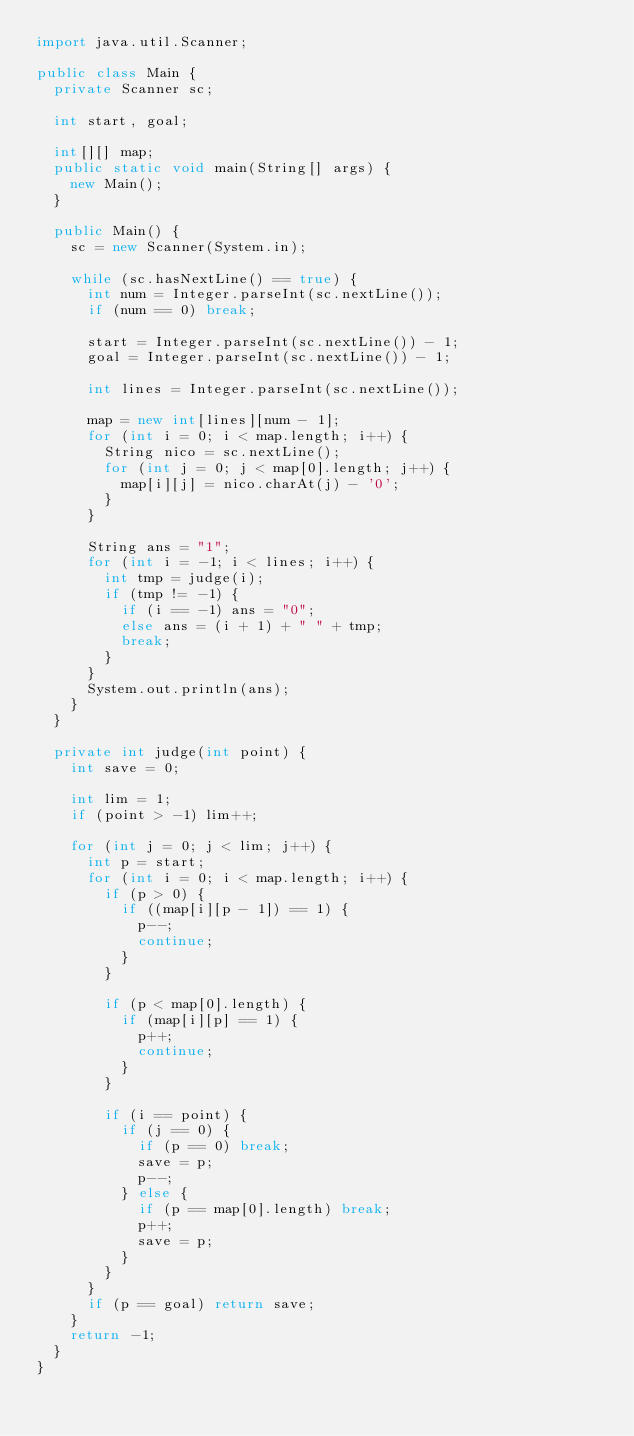<code> <loc_0><loc_0><loc_500><loc_500><_Java_>import java.util.Scanner;

public class Main {
	private Scanner sc;
	
	int start, goal;
	
	int[][] map;
	public static void main(String[] args) {
		new Main();
	}
	
	public Main() {
		sc = new Scanner(System.in);
		
		while (sc.hasNextLine() == true) {
			int num = Integer.parseInt(sc.nextLine());
			if (num == 0) break;
			
			start = Integer.parseInt(sc.nextLine()) - 1;
			goal = Integer.parseInt(sc.nextLine()) - 1;
			
			int lines = Integer.parseInt(sc.nextLine());
			
			map = new int[lines][num - 1];
			for (int i = 0; i < map.length; i++) {
				String nico = sc.nextLine();
				for (int j = 0; j < map[0].length; j++) {
					map[i][j] = nico.charAt(j) - '0';
				}
			}
			
			String ans = "1";
			for (int i = -1; i < lines; i++) {
				int tmp = judge(i);
				if (tmp != -1) {
					if (i == -1) ans = "0";
					else ans = (i + 1) + " " + tmp;
					break;
				}
			}
			System.out.println(ans);
		}
	}
	
	private int judge(int point) {
		int save = 0;
		
		int lim = 1;
		if (point > -1) lim++;
		
		for (int j = 0; j < lim; j++) {
			int p = start;
			for (int i = 0; i < map.length; i++) {
				if (p > 0) {
					if ((map[i][p - 1]) == 1) {
						p--;
						continue;
					}
				}
				
				if (p < map[0].length) {
					if (map[i][p] == 1) {
						p++;
						continue;
					}
				}
				
				if (i == point) {
					if (j == 0) {
						if (p == 0) break;
						save = p;
						p--;
					} else {
						if (p == map[0].length) break;
						p++;
						save = p;
					}
				}
			}
			if (p == goal) return save;
		}
		return -1;
	}
}</code> 